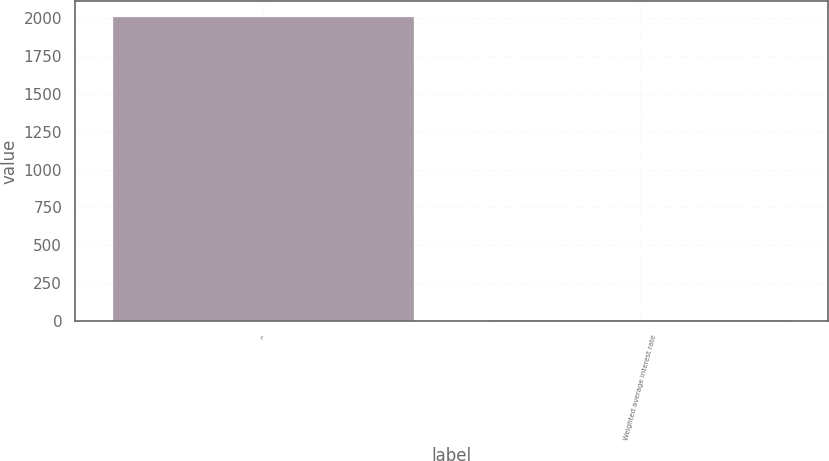Convert chart. <chart><loc_0><loc_0><loc_500><loc_500><bar_chart><fcel>^<fcel>Weighted average interest rate<nl><fcel>2011<fcel>4.19<nl></chart> 